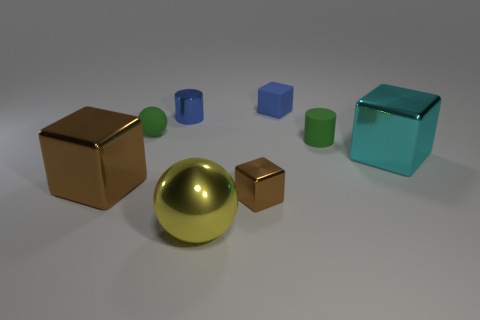Subtract 1 cubes. How many cubes are left? 3 Add 1 spheres. How many objects exist? 9 Subtract all spheres. How many objects are left? 6 Subtract 1 blue cubes. How many objects are left? 7 Subtract all blue shiny things. Subtract all purple shiny objects. How many objects are left? 7 Add 1 green spheres. How many green spheres are left? 2 Add 6 blue metallic cylinders. How many blue metallic cylinders exist? 7 